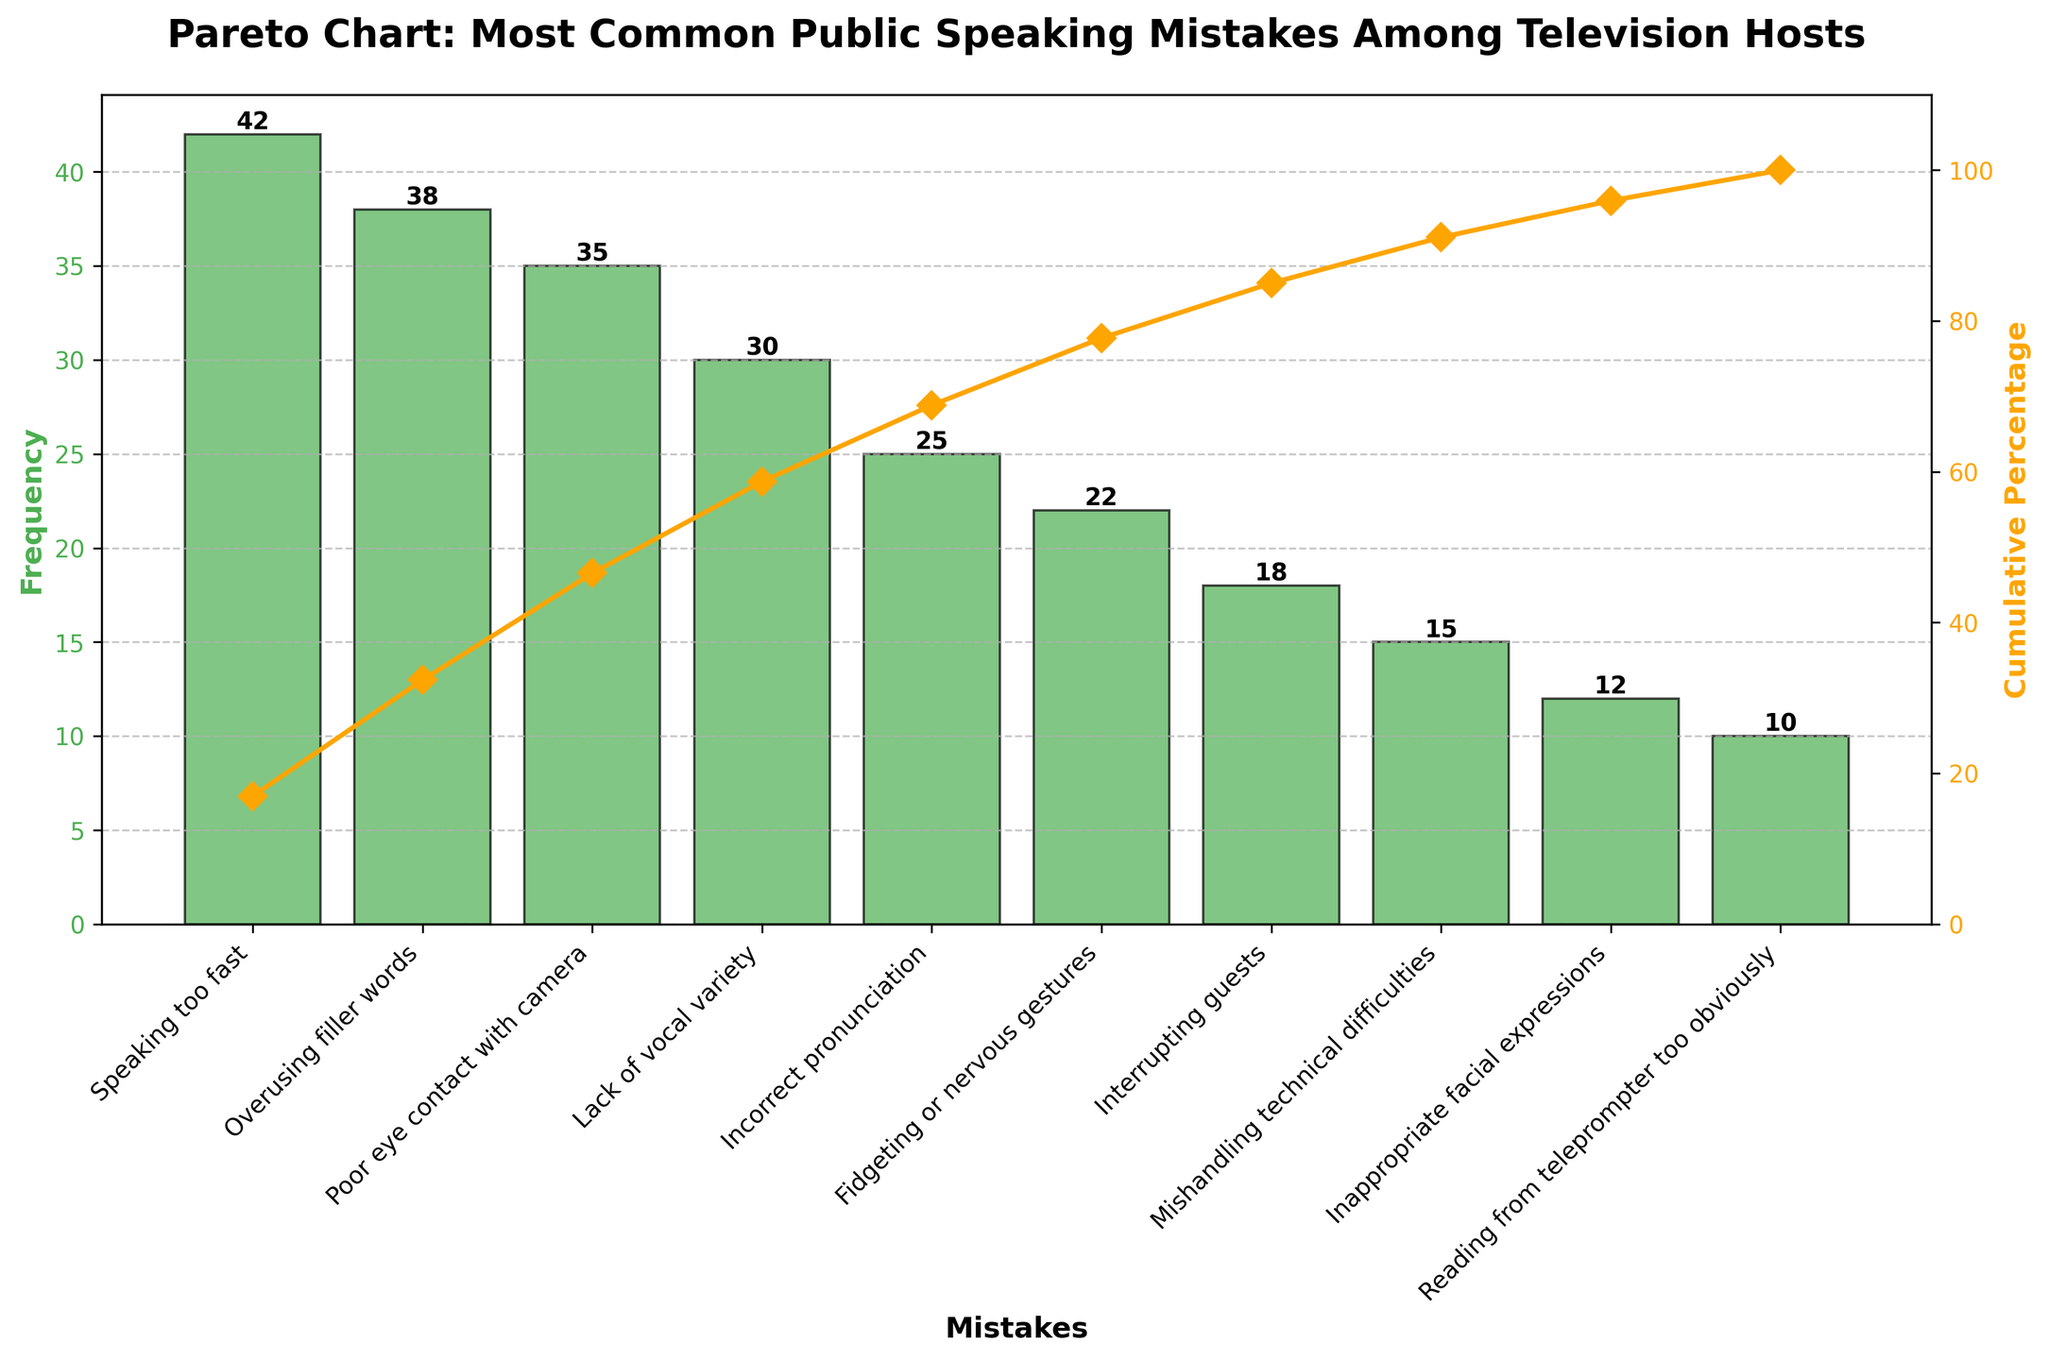What is the most common public speaking mistake? The tallest bar on the chart represents the most common mistake, which is "Speaking too fast" with a frequency of 42.
Answer: Speaking too fast How many mistakes have a frequency of more than 30? Checking the bars with frequencies more than 30, we see "Speaking too fast" (42), "Overusing filler words" (38), "Poor eye contact with camera" (35), and "Lack of vocal variety" (30).
Answer: 3 Which mistake has the lowest frequency? The shortest bar on the chart corresponds to "Reading from teleprompter too obviously" with a frequency of 10.
Answer: Reading from teleprompter too obviously What is the cumulative percentage for the three most frequent mistakes? Adding the cumulative percentages for "Speaking too fast" (21.43%), "Overusing filler words" (41.76%), and "Poor eye contact with camera" (60.99%) gives a total of 60.99%.
Answer: 60.99% What percentage of mistakes is covered by the top four mistakes? The cumulative percentage for "Speaking too fast" (21.43%), "Overusing filler words" (41.76%), "Poor eye contact with camera" (60.99%), and "Lack of vocal variety" (76.28%) need to be added up, giving 76.28%.
Answer: 76.28% Which mistakes have a frequency between 15 and 25? The bars representing frequencies between 15 and 25 are "Incorrect pronunciation" (25), "Fidgeting or nervous gestures" (22), "Interrupting guests" (18), and "Mishandling technical difficulties" (15).
Answer: "Incorrect pronunciation," "Fidgeting or nervous gestures," "Interrupting guests," and "Mishandling technical difficulties" How does the frequency of "Incorrect pronunciation" compare with "Fidgeting or nervous gestures"? The frequency of "Incorrect pronunciation" (25) is higher than "Fidgeting or nervous gestures" (22) by 3.
Answer: 3 What is the cumulative percentage for all mistakes combined? The cumulative percentage for all mistakes combined is 100%, indicating the total proportion of occurrences covered by all the mistakes.
Answer: 100% How many mistakes have been identified in the chart? Counting the number of bars, we see there are 10 different mistakes identified in the chart.
Answer: 10 